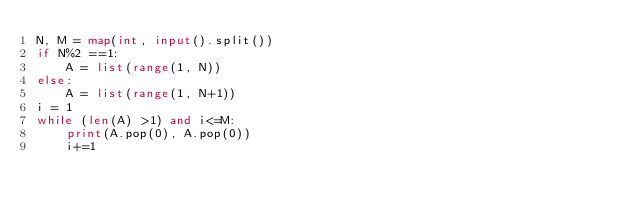Convert code to text. <code><loc_0><loc_0><loc_500><loc_500><_Python_>N, M = map(int, input().split())
if N%2 ==1:
    A = list(range(1, N))
else:
    A = list(range(1, N+1))
i = 1
while (len(A) >1) and i<=M:
    print(A.pop(0), A.pop(0))
    i+=1</code> 